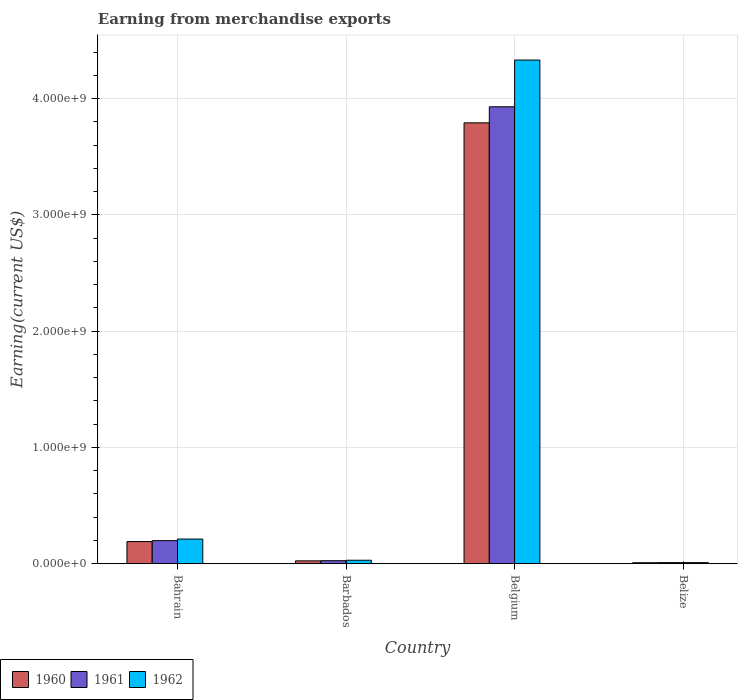How many groups of bars are there?
Keep it short and to the point. 4. Are the number of bars per tick equal to the number of legend labels?
Your answer should be compact. Yes. What is the label of the 4th group of bars from the left?
Keep it short and to the point. Belize. In how many cases, is the number of bars for a given country not equal to the number of legend labels?
Provide a short and direct response. 0. What is the amount earned from merchandise exports in 1961 in Barbados?
Your answer should be very brief. 2.52e+07. Across all countries, what is the maximum amount earned from merchandise exports in 1962?
Keep it short and to the point. 4.33e+09. Across all countries, what is the minimum amount earned from merchandise exports in 1962?
Your response must be concise. 8.67e+06. In which country was the amount earned from merchandise exports in 1962 maximum?
Offer a terse response. Belgium. In which country was the amount earned from merchandise exports in 1962 minimum?
Make the answer very short. Belize. What is the total amount earned from merchandise exports in 1962 in the graph?
Offer a very short reply. 4.58e+09. What is the difference between the amount earned from merchandise exports in 1961 in Bahrain and that in Belize?
Your response must be concise. 1.89e+08. What is the difference between the amount earned from merchandise exports in 1962 in Belgium and the amount earned from merchandise exports in 1961 in Bahrain?
Keep it short and to the point. 4.13e+09. What is the average amount earned from merchandise exports in 1961 per country?
Keep it short and to the point. 1.04e+09. What is the difference between the amount earned from merchandise exports of/in 1961 and amount earned from merchandise exports of/in 1962 in Barbados?
Make the answer very short. -4.10e+06. In how many countries, is the amount earned from merchandise exports in 1960 greater than 2400000000 US$?
Offer a very short reply. 1. What is the ratio of the amount earned from merchandise exports in 1962 in Bahrain to that in Belize?
Keep it short and to the point. 24.4. Is the amount earned from merchandise exports in 1961 in Bahrain less than that in Barbados?
Ensure brevity in your answer.  No. Is the difference between the amount earned from merchandise exports in 1961 in Barbados and Belize greater than the difference between the amount earned from merchandise exports in 1962 in Barbados and Belize?
Provide a succinct answer. No. What is the difference between the highest and the second highest amount earned from merchandise exports in 1961?
Make the answer very short. 3.90e+09. What is the difference between the highest and the lowest amount earned from merchandise exports in 1960?
Keep it short and to the point. 3.78e+09. What does the 3rd bar from the left in Bahrain represents?
Offer a terse response. 1962. Are all the bars in the graph horizontal?
Offer a terse response. No. How many countries are there in the graph?
Offer a terse response. 4. What is the difference between two consecutive major ticks on the Y-axis?
Offer a terse response. 1.00e+09. Are the values on the major ticks of Y-axis written in scientific E-notation?
Ensure brevity in your answer.  Yes. Does the graph contain any zero values?
Keep it short and to the point. No. Where does the legend appear in the graph?
Provide a succinct answer. Bottom left. How many legend labels are there?
Give a very brief answer. 3. How are the legend labels stacked?
Make the answer very short. Horizontal. What is the title of the graph?
Ensure brevity in your answer.  Earning from merchandise exports. What is the label or title of the Y-axis?
Your answer should be compact. Earning(current US$). What is the Earning(current US$) of 1960 in Bahrain?
Keep it short and to the point. 1.90e+08. What is the Earning(current US$) in 1961 in Bahrain?
Offer a terse response. 1.98e+08. What is the Earning(current US$) of 1962 in Bahrain?
Keep it short and to the point. 2.12e+08. What is the Earning(current US$) in 1960 in Barbados?
Ensure brevity in your answer.  2.39e+07. What is the Earning(current US$) of 1961 in Barbados?
Ensure brevity in your answer.  2.52e+07. What is the Earning(current US$) in 1962 in Barbados?
Provide a succinct answer. 2.93e+07. What is the Earning(current US$) of 1960 in Belgium?
Your response must be concise. 3.79e+09. What is the Earning(current US$) of 1961 in Belgium?
Your answer should be very brief. 3.93e+09. What is the Earning(current US$) of 1962 in Belgium?
Ensure brevity in your answer.  4.33e+09. What is the Earning(current US$) in 1960 in Belize?
Provide a succinct answer. 7.87e+06. What is the Earning(current US$) of 1961 in Belize?
Your answer should be compact. 8.68e+06. What is the Earning(current US$) in 1962 in Belize?
Give a very brief answer. 8.67e+06. Across all countries, what is the maximum Earning(current US$) in 1960?
Make the answer very short. 3.79e+09. Across all countries, what is the maximum Earning(current US$) in 1961?
Provide a succinct answer. 3.93e+09. Across all countries, what is the maximum Earning(current US$) of 1962?
Offer a very short reply. 4.33e+09. Across all countries, what is the minimum Earning(current US$) in 1960?
Your answer should be compact. 7.87e+06. Across all countries, what is the minimum Earning(current US$) in 1961?
Your answer should be very brief. 8.68e+06. Across all countries, what is the minimum Earning(current US$) of 1962?
Make the answer very short. 8.67e+06. What is the total Earning(current US$) in 1960 in the graph?
Make the answer very short. 4.01e+09. What is the total Earning(current US$) of 1961 in the graph?
Provide a succinct answer. 4.16e+09. What is the total Earning(current US$) in 1962 in the graph?
Your answer should be very brief. 4.58e+09. What is the difference between the Earning(current US$) of 1960 in Bahrain and that in Barbados?
Provide a short and direct response. 1.66e+08. What is the difference between the Earning(current US$) of 1961 in Bahrain and that in Barbados?
Provide a short and direct response. 1.73e+08. What is the difference between the Earning(current US$) of 1962 in Bahrain and that in Barbados?
Offer a very short reply. 1.82e+08. What is the difference between the Earning(current US$) in 1960 in Bahrain and that in Belgium?
Provide a short and direct response. -3.60e+09. What is the difference between the Earning(current US$) of 1961 in Bahrain and that in Belgium?
Offer a terse response. -3.73e+09. What is the difference between the Earning(current US$) of 1962 in Bahrain and that in Belgium?
Make the answer very short. -4.12e+09. What is the difference between the Earning(current US$) in 1960 in Bahrain and that in Belize?
Give a very brief answer. 1.82e+08. What is the difference between the Earning(current US$) in 1961 in Bahrain and that in Belize?
Offer a very short reply. 1.89e+08. What is the difference between the Earning(current US$) of 1962 in Bahrain and that in Belize?
Offer a terse response. 2.03e+08. What is the difference between the Earning(current US$) in 1960 in Barbados and that in Belgium?
Offer a very short reply. -3.77e+09. What is the difference between the Earning(current US$) in 1961 in Barbados and that in Belgium?
Your response must be concise. -3.90e+09. What is the difference between the Earning(current US$) of 1962 in Barbados and that in Belgium?
Provide a short and direct response. -4.30e+09. What is the difference between the Earning(current US$) of 1960 in Barbados and that in Belize?
Your answer should be compact. 1.60e+07. What is the difference between the Earning(current US$) in 1961 in Barbados and that in Belize?
Your response must be concise. 1.65e+07. What is the difference between the Earning(current US$) in 1962 in Barbados and that in Belize?
Your answer should be compact. 2.07e+07. What is the difference between the Earning(current US$) of 1960 in Belgium and that in Belize?
Provide a short and direct response. 3.78e+09. What is the difference between the Earning(current US$) in 1961 in Belgium and that in Belize?
Your response must be concise. 3.92e+09. What is the difference between the Earning(current US$) in 1962 in Belgium and that in Belize?
Offer a very short reply. 4.32e+09. What is the difference between the Earning(current US$) of 1960 in Bahrain and the Earning(current US$) of 1961 in Barbados?
Your response must be concise. 1.65e+08. What is the difference between the Earning(current US$) in 1960 in Bahrain and the Earning(current US$) in 1962 in Barbados?
Ensure brevity in your answer.  1.61e+08. What is the difference between the Earning(current US$) of 1961 in Bahrain and the Earning(current US$) of 1962 in Barbados?
Your response must be concise. 1.69e+08. What is the difference between the Earning(current US$) in 1960 in Bahrain and the Earning(current US$) in 1961 in Belgium?
Your response must be concise. -3.74e+09. What is the difference between the Earning(current US$) of 1960 in Bahrain and the Earning(current US$) of 1962 in Belgium?
Your answer should be compact. -4.14e+09. What is the difference between the Earning(current US$) in 1961 in Bahrain and the Earning(current US$) in 1962 in Belgium?
Give a very brief answer. -4.13e+09. What is the difference between the Earning(current US$) of 1960 in Bahrain and the Earning(current US$) of 1961 in Belize?
Give a very brief answer. 1.81e+08. What is the difference between the Earning(current US$) in 1960 in Bahrain and the Earning(current US$) in 1962 in Belize?
Your response must be concise. 1.81e+08. What is the difference between the Earning(current US$) of 1961 in Bahrain and the Earning(current US$) of 1962 in Belize?
Ensure brevity in your answer.  1.89e+08. What is the difference between the Earning(current US$) of 1960 in Barbados and the Earning(current US$) of 1961 in Belgium?
Keep it short and to the point. -3.91e+09. What is the difference between the Earning(current US$) in 1960 in Barbados and the Earning(current US$) in 1962 in Belgium?
Offer a very short reply. -4.31e+09. What is the difference between the Earning(current US$) in 1961 in Barbados and the Earning(current US$) in 1962 in Belgium?
Provide a succinct answer. -4.31e+09. What is the difference between the Earning(current US$) in 1960 in Barbados and the Earning(current US$) in 1961 in Belize?
Ensure brevity in your answer.  1.52e+07. What is the difference between the Earning(current US$) in 1960 in Barbados and the Earning(current US$) in 1962 in Belize?
Offer a terse response. 1.52e+07. What is the difference between the Earning(current US$) in 1961 in Barbados and the Earning(current US$) in 1962 in Belize?
Keep it short and to the point. 1.66e+07. What is the difference between the Earning(current US$) in 1960 in Belgium and the Earning(current US$) in 1961 in Belize?
Offer a terse response. 3.78e+09. What is the difference between the Earning(current US$) of 1960 in Belgium and the Earning(current US$) of 1962 in Belize?
Make the answer very short. 3.78e+09. What is the difference between the Earning(current US$) of 1961 in Belgium and the Earning(current US$) of 1962 in Belize?
Your answer should be compact. 3.92e+09. What is the average Earning(current US$) of 1960 per country?
Provide a short and direct response. 1.00e+09. What is the average Earning(current US$) of 1961 per country?
Make the answer very short. 1.04e+09. What is the average Earning(current US$) of 1962 per country?
Make the answer very short. 1.15e+09. What is the difference between the Earning(current US$) of 1960 and Earning(current US$) of 1961 in Bahrain?
Your response must be concise. -8.00e+06. What is the difference between the Earning(current US$) of 1960 and Earning(current US$) of 1962 in Bahrain?
Your answer should be compact. -2.15e+07. What is the difference between the Earning(current US$) of 1961 and Earning(current US$) of 1962 in Bahrain?
Ensure brevity in your answer.  -1.35e+07. What is the difference between the Earning(current US$) of 1960 and Earning(current US$) of 1961 in Barbados?
Provide a short and direct response. -1.37e+06. What is the difference between the Earning(current US$) of 1960 and Earning(current US$) of 1962 in Barbados?
Ensure brevity in your answer.  -5.46e+06. What is the difference between the Earning(current US$) of 1961 and Earning(current US$) of 1962 in Barbados?
Make the answer very short. -4.10e+06. What is the difference between the Earning(current US$) in 1960 and Earning(current US$) in 1961 in Belgium?
Offer a very short reply. -1.38e+08. What is the difference between the Earning(current US$) in 1960 and Earning(current US$) in 1962 in Belgium?
Provide a short and direct response. -5.40e+08. What is the difference between the Earning(current US$) in 1961 and Earning(current US$) in 1962 in Belgium?
Provide a short and direct response. -4.02e+08. What is the difference between the Earning(current US$) in 1960 and Earning(current US$) in 1961 in Belize?
Keep it short and to the point. -8.10e+05. What is the difference between the Earning(current US$) of 1960 and Earning(current US$) of 1962 in Belize?
Provide a succinct answer. -7.95e+05. What is the difference between the Earning(current US$) of 1961 and Earning(current US$) of 1962 in Belize?
Ensure brevity in your answer.  1.47e+04. What is the ratio of the Earning(current US$) of 1960 in Bahrain to that in Barbados?
Your answer should be compact. 7.96. What is the ratio of the Earning(current US$) in 1961 in Bahrain to that in Barbados?
Provide a short and direct response. 7.85. What is the ratio of the Earning(current US$) of 1962 in Bahrain to that in Barbados?
Your answer should be very brief. 7.21. What is the ratio of the Earning(current US$) of 1960 in Bahrain to that in Belgium?
Your answer should be compact. 0.05. What is the ratio of the Earning(current US$) of 1961 in Bahrain to that in Belgium?
Provide a succinct answer. 0.05. What is the ratio of the Earning(current US$) of 1962 in Bahrain to that in Belgium?
Offer a terse response. 0.05. What is the ratio of the Earning(current US$) of 1960 in Bahrain to that in Belize?
Provide a succinct answer. 24.14. What is the ratio of the Earning(current US$) in 1961 in Bahrain to that in Belize?
Offer a terse response. 22.81. What is the ratio of the Earning(current US$) of 1962 in Bahrain to that in Belize?
Offer a terse response. 24.4. What is the ratio of the Earning(current US$) in 1960 in Barbados to that in Belgium?
Your answer should be compact. 0.01. What is the ratio of the Earning(current US$) of 1961 in Barbados to that in Belgium?
Your response must be concise. 0.01. What is the ratio of the Earning(current US$) in 1962 in Barbados to that in Belgium?
Offer a terse response. 0.01. What is the ratio of the Earning(current US$) of 1960 in Barbados to that in Belize?
Keep it short and to the point. 3.03. What is the ratio of the Earning(current US$) of 1961 in Barbados to that in Belize?
Offer a terse response. 2.91. What is the ratio of the Earning(current US$) of 1962 in Barbados to that in Belize?
Make the answer very short. 3.38. What is the ratio of the Earning(current US$) of 1960 in Belgium to that in Belize?
Provide a succinct answer. 481.74. What is the ratio of the Earning(current US$) of 1961 in Belgium to that in Belize?
Offer a very short reply. 452.69. What is the ratio of the Earning(current US$) of 1962 in Belgium to that in Belize?
Keep it short and to the point. 499.84. What is the difference between the highest and the second highest Earning(current US$) of 1960?
Provide a short and direct response. 3.60e+09. What is the difference between the highest and the second highest Earning(current US$) of 1961?
Make the answer very short. 3.73e+09. What is the difference between the highest and the second highest Earning(current US$) in 1962?
Your response must be concise. 4.12e+09. What is the difference between the highest and the lowest Earning(current US$) in 1960?
Provide a succinct answer. 3.78e+09. What is the difference between the highest and the lowest Earning(current US$) of 1961?
Keep it short and to the point. 3.92e+09. What is the difference between the highest and the lowest Earning(current US$) of 1962?
Give a very brief answer. 4.32e+09. 